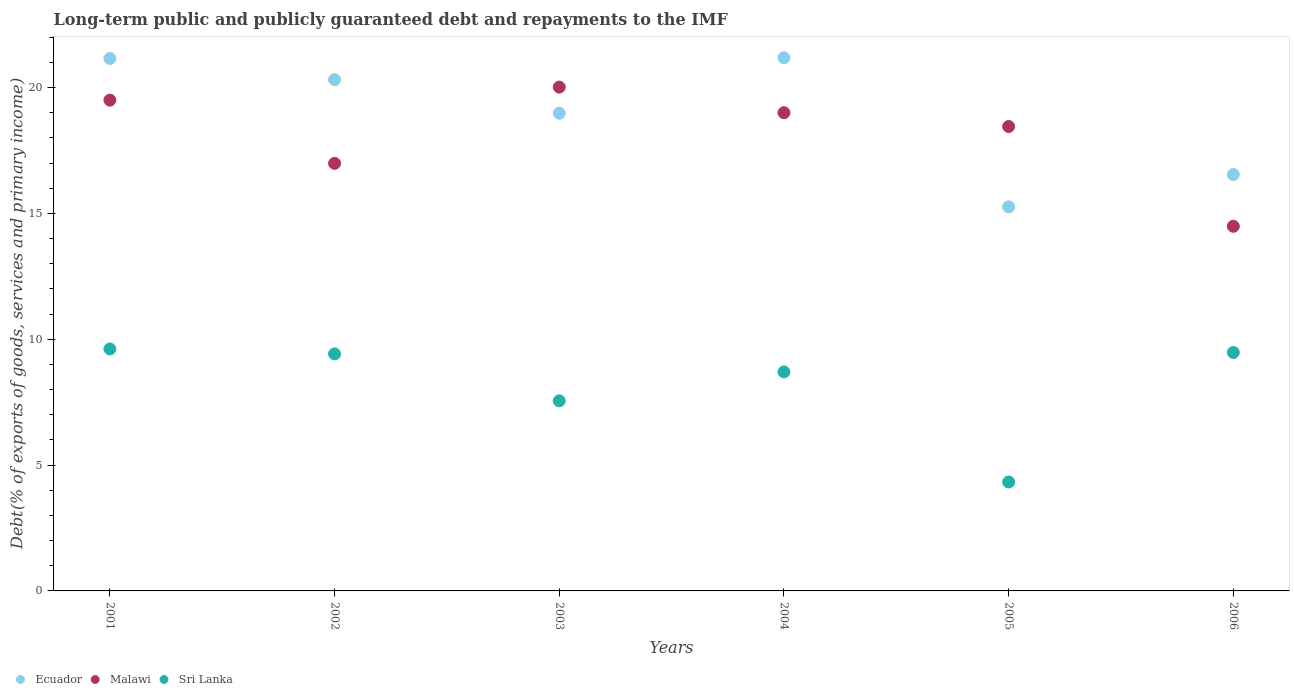Is the number of dotlines equal to the number of legend labels?
Your answer should be compact. Yes. What is the debt and repayments in Sri Lanka in 2002?
Your answer should be very brief. 9.42. Across all years, what is the maximum debt and repayments in Ecuador?
Provide a succinct answer. 21.18. Across all years, what is the minimum debt and repayments in Sri Lanka?
Your answer should be compact. 4.33. In which year was the debt and repayments in Sri Lanka minimum?
Provide a short and direct response. 2005. What is the total debt and repayments in Ecuador in the graph?
Give a very brief answer. 113.44. What is the difference between the debt and repayments in Ecuador in 2004 and that in 2005?
Make the answer very short. 5.92. What is the difference between the debt and repayments in Malawi in 2006 and the debt and repayments in Ecuador in 2001?
Offer a very short reply. -6.67. What is the average debt and repayments in Ecuador per year?
Provide a short and direct response. 18.91. In the year 2005, what is the difference between the debt and repayments in Ecuador and debt and repayments in Malawi?
Keep it short and to the point. -3.19. In how many years, is the debt and repayments in Malawi greater than 4 %?
Offer a very short reply. 6. What is the ratio of the debt and repayments in Malawi in 2002 to that in 2003?
Offer a very short reply. 0.85. Is the debt and repayments in Sri Lanka in 2004 less than that in 2005?
Your answer should be compact. No. Is the difference between the debt and repayments in Ecuador in 2002 and 2006 greater than the difference between the debt and repayments in Malawi in 2002 and 2006?
Make the answer very short. Yes. What is the difference between the highest and the second highest debt and repayments in Ecuador?
Keep it short and to the point. 0.03. What is the difference between the highest and the lowest debt and repayments in Ecuador?
Your answer should be compact. 5.92. In how many years, is the debt and repayments in Malawi greater than the average debt and repayments in Malawi taken over all years?
Offer a very short reply. 4. Is the sum of the debt and repayments in Malawi in 2003 and 2005 greater than the maximum debt and repayments in Ecuador across all years?
Give a very brief answer. Yes. Is it the case that in every year, the sum of the debt and repayments in Malawi and debt and repayments in Ecuador  is greater than the debt and repayments in Sri Lanka?
Ensure brevity in your answer.  Yes. Is the debt and repayments in Ecuador strictly greater than the debt and repayments in Sri Lanka over the years?
Provide a succinct answer. Yes. Is the debt and repayments in Sri Lanka strictly less than the debt and repayments in Malawi over the years?
Ensure brevity in your answer.  Yes. What is the difference between two consecutive major ticks on the Y-axis?
Your answer should be very brief. 5. Does the graph contain any zero values?
Offer a very short reply. No. Does the graph contain grids?
Give a very brief answer. No. Where does the legend appear in the graph?
Give a very brief answer. Bottom left. What is the title of the graph?
Provide a short and direct response. Long-term public and publicly guaranteed debt and repayments to the IMF. Does "Least developed countries" appear as one of the legend labels in the graph?
Provide a succinct answer. No. What is the label or title of the X-axis?
Make the answer very short. Years. What is the label or title of the Y-axis?
Your answer should be compact. Debt(% of exports of goods, services and primary income). What is the Debt(% of exports of goods, services and primary income) in Ecuador in 2001?
Provide a succinct answer. 21.15. What is the Debt(% of exports of goods, services and primary income) in Malawi in 2001?
Ensure brevity in your answer.  19.5. What is the Debt(% of exports of goods, services and primary income) in Sri Lanka in 2001?
Provide a short and direct response. 9.61. What is the Debt(% of exports of goods, services and primary income) in Ecuador in 2002?
Your response must be concise. 20.32. What is the Debt(% of exports of goods, services and primary income) in Malawi in 2002?
Give a very brief answer. 16.99. What is the Debt(% of exports of goods, services and primary income) of Sri Lanka in 2002?
Make the answer very short. 9.42. What is the Debt(% of exports of goods, services and primary income) of Ecuador in 2003?
Your answer should be very brief. 18.98. What is the Debt(% of exports of goods, services and primary income) in Malawi in 2003?
Give a very brief answer. 20.02. What is the Debt(% of exports of goods, services and primary income) in Sri Lanka in 2003?
Your response must be concise. 7.55. What is the Debt(% of exports of goods, services and primary income) of Ecuador in 2004?
Give a very brief answer. 21.18. What is the Debt(% of exports of goods, services and primary income) of Malawi in 2004?
Make the answer very short. 19. What is the Debt(% of exports of goods, services and primary income) of Sri Lanka in 2004?
Offer a very short reply. 8.7. What is the Debt(% of exports of goods, services and primary income) in Ecuador in 2005?
Give a very brief answer. 15.26. What is the Debt(% of exports of goods, services and primary income) in Malawi in 2005?
Give a very brief answer. 18.45. What is the Debt(% of exports of goods, services and primary income) in Sri Lanka in 2005?
Provide a succinct answer. 4.33. What is the Debt(% of exports of goods, services and primary income) of Ecuador in 2006?
Your response must be concise. 16.54. What is the Debt(% of exports of goods, services and primary income) of Malawi in 2006?
Offer a very short reply. 14.49. What is the Debt(% of exports of goods, services and primary income) in Sri Lanka in 2006?
Provide a short and direct response. 9.47. Across all years, what is the maximum Debt(% of exports of goods, services and primary income) in Ecuador?
Your answer should be very brief. 21.18. Across all years, what is the maximum Debt(% of exports of goods, services and primary income) of Malawi?
Offer a terse response. 20.02. Across all years, what is the maximum Debt(% of exports of goods, services and primary income) of Sri Lanka?
Provide a short and direct response. 9.61. Across all years, what is the minimum Debt(% of exports of goods, services and primary income) in Ecuador?
Make the answer very short. 15.26. Across all years, what is the minimum Debt(% of exports of goods, services and primary income) of Malawi?
Ensure brevity in your answer.  14.49. Across all years, what is the minimum Debt(% of exports of goods, services and primary income) in Sri Lanka?
Your answer should be very brief. 4.33. What is the total Debt(% of exports of goods, services and primary income) of Ecuador in the graph?
Your answer should be compact. 113.44. What is the total Debt(% of exports of goods, services and primary income) in Malawi in the graph?
Provide a short and direct response. 108.45. What is the total Debt(% of exports of goods, services and primary income) of Sri Lanka in the graph?
Provide a succinct answer. 49.09. What is the difference between the Debt(% of exports of goods, services and primary income) of Ecuador in 2001 and that in 2002?
Your answer should be very brief. 0.84. What is the difference between the Debt(% of exports of goods, services and primary income) of Malawi in 2001 and that in 2002?
Your answer should be very brief. 2.51. What is the difference between the Debt(% of exports of goods, services and primary income) in Sri Lanka in 2001 and that in 2002?
Your answer should be compact. 0.2. What is the difference between the Debt(% of exports of goods, services and primary income) of Ecuador in 2001 and that in 2003?
Make the answer very short. 2.17. What is the difference between the Debt(% of exports of goods, services and primary income) of Malawi in 2001 and that in 2003?
Your answer should be compact. -0.52. What is the difference between the Debt(% of exports of goods, services and primary income) of Sri Lanka in 2001 and that in 2003?
Keep it short and to the point. 2.06. What is the difference between the Debt(% of exports of goods, services and primary income) in Ecuador in 2001 and that in 2004?
Make the answer very short. -0.03. What is the difference between the Debt(% of exports of goods, services and primary income) of Malawi in 2001 and that in 2004?
Your answer should be compact. 0.5. What is the difference between the Debt(% of exports of goods, services and primary income) of Sri Lanka in 2001 and that in 2004?
Offer a terse response. 0.91. What is the difference between the Debt(% of exports of goods, services and primary income) in Ecuador in 2001 and that in 2005?
Offer a very short reply. 5.89. What is the difference between the Debt(% of exports of goods, services and primary income) in Malawi in 2001 and that in 2005?
Ensure brevity in your answer.  1.05. What is the difference between the Debt(% of exports of goods, services and primary income) of Sri Lanka in 2001 and that in 2005?
Your response must be concise. 5.29. What is the difference between the Debt(% of exports of goods, services and primary income) of Ecuador in 2001 and that in 2006?
Provide a short and direct response. 4.61. What is the difference between the Debt(% of exports of goods, services and primary income) of Malawi in 2001 and that in 2006?
Your answer should be very brief. 5.01. What is the difference between the Debt(% of exports of goods, services and primary income) of Sri Lanka in 2001 and that in 2006?
Provide a short and direct response. 0.14. What is the difference between the Debt(% of exports of goods, services and primary income) of Ecuador in 2002 and that in 2003?
Give a very brief answer. 1.34. What is the difference between the Debt(% of exports of goods, services and primary income) of Malawi in 2002 and that in 2003?
Your answer should be very brief. -3.03. What is the difference between the Debt(% of exports of goods, services and primary income) in Sri Lanka in 2002 and that in 2003?
Your answer should be very brief. 1.86. What is the difference between the Debt(% of exports of goods, services and primary income) in Ecuador in 2002 and that in 2004?
Give a very brief answer. -0.87. What is the difference between the Debt(% of exports of goods, services and primary income) of Malawi in 2002 and that in 2004?
Provide a succinct answer. -2.01. What is the difference between the Debt(% of exports of goods, services and primary income) of Sri Lanka in 2002 and that in 2004?
Give a very brief answer. 0.72. What is the difference between the Debt(% of exports of goods, services and primary income) in Ecuador in 2002 and that in 2005?
Your response must be concise. 5.06. What is the difference between the Debt(% of exports of goods, services and primary income) of Malawi in 2002 and that in 2005?
Provide a short and direct response. -1.46. What is the difference between the Debt(% of exports of goods, services and primary income) in Sri Lanka in 2002 and that in 2005?
Provide a short and direct response. 5.09. What is the difference between the Debt(% of exports of goods, services and primary income) of Ecuador in 2002 and that in 2006?
Keep it short and to the point. 3.77. What is the difference between the Debt(% of exports of goods, services and primary income) of Malawi in 2002 and that in 2006?
Offer a terse response. 2.5. What is the difference between the Debt(% of exports of goods, services and primary income) in Sri Lanka in 2002 and that in 2006?
Keep it short and to the point. -0.06. What is the difference between the Debt(% of exports of goods, services and primary income) in Ecuador in 2003 and that in 2004?
Your response must be concise. -2.2. What is the difference between the Debt(% of exports of goods, services and primary income) in Malawi in 2003 and that in 2004?
Ensure brevity in your answer.  1.02. What is the difference between the Debt(% of exports of goods, services and primary income) of Sri Lanka in 2003 and that in 2004?
Keep it short and to the point. -1.15. What is the difference between the Debt(% of exports of goods, services and primary income) of Ecuador in 2003 and that in 2005?
Provide a short and direct response. 3.72. What is the difference between the Debt(% of exports of goods, services and primary income) of Malawi in 2003 and that in 2005?
Make the answer very short. 1.56. What is the difference between the Debt(% of exports of goods, services and primary income) of Sri Lanka in 2003 and that in 2005?
Your response must be concise. 3.23. What is the difference between the Debt(% of exports of goods, services and primary income) in Ecuador in 2003 and that in 2006?
Ensure brevity in your answer.  2.44. What is the difference between the Debt(% of exports of goods, services and primary income) in Malawi in 2003 and that in 2006?
Your answer should be compact. 5.53. What is the difference between the Debt(% of exports of goods, services and primary income) of Sri Lanka in 2003 and that in 2006?
Provide a succinct answer. -1.92. What is the difference between the Debt(% of exports of goods, services and primary income) in Ecuador in 2004 and that in 2005?
Your answer should be very brief. 5.92. What is the difference between the Debt(% of exports of goods, services and primary income) in Malawi in 2004 and that in 2005?
Your answer should be very brief. 0.55. What is the difference between the Debt(% of exports of goods, services and primary income) in Sri Lanka in 2004 and that in 2005?
Give a very brief answer. 4.37. What is the difference between the Debt(% of exports of goods, services and primary income) in Ecuador in 2004 and that in 2006?
Your answer should be very brief. 4.64. What is the difference between the Debt(% of exports of goods, services and primary income) of Malawi in 2004 and that in 2006?
Provide a succinct answer. 4.51. What is the difference between the Debt(% of exports of goods, services and primary income) in Sri Lanka in 2004 and that in 2006?
Offer a terse response. -0.77. What is the difference between the Debt(% of exports of goods, services and primary income) in Ecuador in 2005 and that in 2006?
Your answer should be very brief. -1.28. What is the difference between the Debt(% of exports of goods, services and primary income) in Malawi in 2005 and that in 2006?
Provide a succinct answer. 3.97. What is the difference between the Debt(% of exports of goods, services and primary income) of Sri Lanka in 2005 and that in 2006?
Ensure brevity in your answer.  -5.15. What is the difference between the Debt(% of exports of goods, services and primary income) of Ecuador in 2001 and the Debt(% of exports of goods, services and primary income) of Malawi in 2002?
Give a very brief answer. 4.17. What is the difference between the Debt(% of exports of goods, services and primary income) of Ecuador in 2001 and the Debt(% of exports of goods, services and primary income) of Sri Lanka in 2002?
Your response must be concise. 11.74. What is the difference between the Debt(% of exports of goods, services and primary income) in Malawi in 2001 and the Debt(% of exports of goods, services and primary income) in Sri Lanka in 2002?
Your answer should be compact. 10.08. What is the difference between the Debt(% of exports of goods, services and primary income) in Ecuador in 2001 and the Debt(% of exports of goods, services and primary income) in Malawi in 2003?
Offer a very short reply. 1.14. What is the difference between the Debt(% of exports of goods, services and primary income) in Ecuador in 2001 and the Debt(% of exports of goods, services and primary income) in Sri Lanka in 2003?
Your answer should be very brief. 13.6. What is the difference between the Debt(% of exports of goods, services and primary income) in Malawi in 2001 and the Debt(% of exports of goods, services and primary income) in Sri Lanka in 2003?
Keep it short and to the point. 11.95. What is the difference between the Debt(% of exports of goods, services and primary income) of Ecuador in 2001 and the Debt(% of exports of goods, services and primary income) of Malawi in 2004?
Offer a terse response. 2.15. What is the difference between the Debt(% of exports of goods, services and primary income) in Ecuador in 2001 and the Debt(% of exports of goods, services and primary income) in Sri Lanka in 2004?
Ensure brevity in your answer.  12.45. What is the difference between the Debt(% of exports of goods, services and primary income) in Malawi in 2001 and the Debt(% of exports of goods, services and primary income) in Sri Lanka in 2004?
Your answer should be very brief. 10.8. What is the difference between the Debt(% of exports of goods, services and primary income) in Ecuador in 2001 and the Debt(% of exports of goods, services and primary income) in Malawi in 2005?
Keep it short and to the point. 2.7. What is the difference between the Debt(% of exports of goods, services and primary income) in Ecuador in 2001 and the Debt(% of exports of goods, services and primary income) in Sri Lanka in 2005?
Give a very brief answer. 16.83. What is the difference between the Debt(% of exports of goods, services and primary income) of Malawi in 2001 and the Debt(% of exports of goods, services and primary income) of Sri Lanka in 2005?
Keep it short and to the point. 15.17. What is the difference between the Debt(% of exports of goods, services and primary income) in Ecuador in 2001 and the Debt(% of exports of goods, services and primary income) in Malawi in 2006?
Your answer should be very brief. 6.67. What is the difference between the Debt(% of exports of goods, services and primary income) of Ecuador in 2001 and the Debt(% of exports of goods, services and primary income) of Sri Lanka in 2006?
Offer a very short reply. 11.68. What is the difference between the Debt(% of exports of goods, services and primary income) in Malawi in 2001 and the Debt(% of exports of goods, services and primary income) in Sri Lanka in 2006?
Give a very brief answer. 10.03. What is the difference between the Debt(% of exports of goods, services and primary income) of Ecuador in 2002 and the Debt(% of exports of goods, services and primary income) of Malawi in 2003?
Ensure brevity in your answer.  0.3. What is the difference between the Debt(% of exports of goods, services and primary income) of Ecuador in 2002 and the Debt(% of exports of goods, services and primary income) of Sri Lanka in 2003?
Your response must be concise. 12.76. What is the difference between the Debt(% of exports of goods, services and primary income) in Malawi in 2002 and the Debt(% of exports of goods, services and primary income) in Sri Lanka in 2003?
Provide a succinct answer. 9.44. What is the difference between the Debt(% of exports of goods, services and primary income) of Ecuador in 2002 and the Debt(% of exports of goods, services and primary income) of Malawi in 2004?
Your response must be concise. 1.31. What is the difference between the Debt(% of exports of goods, services and primary income) in Ecuador in 2002 and the Debt(% of exports of goods, services and primary income) in Sri Lanka in 2004?
Provide a short and direct response. 11.61. What is the difference between the Debt(% of exports of goods, services and primary income) of Malawi in 2002 and the Debt(% of exports of goods, services and primary income) of Sri Lanka in 2004?
Your response must be concise. 8.29. What is the difference between the Debt(% of exports of goods, services and primary income) of Ecuador in 2002 and the Debt(% of exports of goods, services and primary income) of Malawi in 2005?
Your answer should be very brief. 1.86. What is the difference between the Debt(% of exports of goods, services and primary income) of Ecuador in 2002 and the Debt(% of exports of goods, services and primary income) of Sri Lanka in 2005?
Offer a terse response. 15.99. What is the difference between the Debt(% of exports of goods, services and primary income) in Malawi in 2002 and the Debt(% of exports of goods, services and primary income) in Sri Lanka in 2005?
Give a very brief answer. 12.66. What is the difference between the Debt(% of exports of goods, services and primary income) in Ecuador in 2002 and the Debt(% of exports of goods, services and primary income) in Malawi in 2006?
Keep it short and to the point. 5.83. What is the difference between the Debt(% of exports of goods, services and primary income) in Ecuador in 2002 and the Debt(% of exports of goods, services and primary income) in Sri Lanka in 2006?
Give a very brief answer. 10.84. What is the difference between the Debt(% of exports of goods, services and primary income) in Malawi in 2002 and the Debt(% of exports of goods, services and primary income) in Sri Lanka in 2006?
Your response must be concise. 7.51. What is the difference between the Debt(% of exports of goods, services and primary income) of Ecuador in 2003 and the Debt(% of exports of goods, services and primary income) of Malawi in 2004?
Give a very brief answer. -0.02. What is the difference between the Debt(% of exports of goods, services and primary income) of Ecuador in 2003 and the Debt(% of exports of goods, services and primary income) of Sri Lanka in 2004?
Your answer should be compact. 10.28. What is the difference between the Debt(% of exports of goods, services and primary income) in Malawi in 2003 and the Debt(% of exports of goods, services and primary income) in Sri Lanka in 2004?
Give a very brief answer. 11.32. What is the difference between the Debt(% of exports of goods, services and primary income) in Ecuador in 2003 and the Debt(% of exports of goods, services and primary income) in Malawi in 2005?
Your answer should be very brief. 0.53. What is the difference between the Debt(% of exports of goods, services and primary income) in Ecuador in 2003 and the Debt(% of exports of goods, services and primary income) in Sri Lanka in 2005?
Offer a terse response. 14.65. What is the difference between the Debt(% of exports of goods, services and primary income) of Malawi in 2003 and the Debt(% of exports of goods, services and primary income) of Sri Lanka in 2005?
Provide a succinct answer. 15.69. What is the difference between the Debt(% of exports of goods, services and primary income) of Ecuador in 2003 and the Debt(% of exports of goods, services and primary income) of Malawi in 2006?
Provide a succinct answer. 4.49. What is the difference between the Debt(% of exports of goods, services and primary income) of Ecuador in 2003 and the Debt(% of exports of goods, services and primary income) of Sri Lanka in 2006?
Provide a succinct answer. 9.51. What is the difference between the Debt(% of exports of goods, services and primary income) of Malawi in 2003 and the Debt(% of exports of goods, services and primary income) of Sri Lanka in 2006?
Your answer should be compact. 10.54. What is the difference between the Debt(% of exports of goods, services and primary income) in Ecuador in 2004 and the Debt(% of exports of goods, services and primary income) in Malawi in 2005?
Give a very brief answer. 2.73. What is the difference between the Debt(% of exports of goods, services and primary income) in Ecuador in 2004 and the Debt(% of exports of goods, services and primary income) in Sri Lanka in 2005?
Offer a terse response. 16.86. What is the difference between the Debt(% of exports of goods, services and primary income) in Malawi in 2004 and the Debt(% of exports of goods, services and primary income) in Sri Lanka in 2005?
Your answer should be very brief. 14.67. What is the difference between the Debt(% of exports of goods, services and primary income) of Ecuador in 2004 and the Debt(% of exports of goods, services and primary income) of Malawi in 2006?
Your answer should be very brief. 6.69. What is the difference between the Debt(% of exports of goods, services and primary income) in Ecuador in 2004 and the Debt(% of exports of goods, services and primary income) in Sri Lanka in 2006?
Make the answer very short. 11.71. What is the difference between the Debt(% of exports of goods, services and primary income) in Malawi in 2004 and the Debt(% of exports of goods, services and primary income) in Sri Lanka in 2006?
Make the answer very short. 9.53. What is the difference between the Debt(% of exports of goods, services and primary income) of Ecuador in 2005 and the Debt(% of exports of goods, services and primary income) of Malawi in 2006?
Your answer should be very brief. 0.77. What is the difference between the Debt(% of exports of goods, services and primary income) in Ecuador in 2005 and the Debt(% of exports of goods, services and primary income) in Sri Lanka in 2006?
Keep it short and to the point. 5.79. What is the difference between the Debt(% of exports of goods, services and primary income) in Malawi in 2005 and the Debt(% of exports of goods, services and primary income) in Sri Lanka in 2006?
Keep it short and to the point. 8.98. What is the average Debt(% of exports of goods, services and primary income) of Ecuador per year?
Your answer should be compact. 18.91. What is the average Debt(% of exports of goods, services and primary income) in Malawi per year?
Your answer should be very brief. 18.08. What is the average Debt(% of exports of goods, services and primary income) in Sri Lanka per year?
Your answer should be compact. 8.18. In the year 2001, what is the difference between the Debt(% of exports of goods, services and primary income) of Ecuador and Debt(% of exports of goods, services and primary income) of Malawi?
Your answer should be very brief. 1.65. In the year 2001, what is the difference between the Debt(% of exports of goods, services and primary income) of Ecuador and Debt(% of exports of goods, services and primary income) of Sri Lanka?
Ensure brevity in your answer.  11.54. In the year 2001, what is the difference between the Debt(% of exports of goods, services and primary income) of Malawi and Debt(% of exports of goods, services and primary income) of Sri Lanka?
Your answer should be compact. 9.89. In the year 2002, what is the difference between the Debt(% of exports of goods, services and primary income) of Ecuador and Debt(% of exports of goods, services and primary income) of Malawi?
Give a very brief answer. 3.33. In the year 2002, what is the difference between the Debt(% of exports of goods, services and primary income) of Ecuador and Debt(% of exports of goods, services and primary income) of Sri Lanka?
Keep it short and to the point. 10.9. In the year 2002, what is the difference between the Debt(% of exports of goods, services and primary income) in Malawi and Debt(% of exports of goods, services and primary income) in Sri Lanka?
Give a very brief answer. 7.57. In the year 2003, what is the difference between the Debt(% of exports of goods, services and primary income) in Ecuador and Debt(% of exports of goods, services and primary income) in Malawi?
Keep it short and to the point. -1.04. In the year 2003, what is the difference between the Debt(% of exports of goods, services and primary income) in Ecuador and Debt(% of exports of goods, services and primary income) in Sri Lanka?
Your answer should be very brief. 11.43. In the year 2003, what is the difference between the Debt(% of exports of goods, services and primary income) in Malawi and Debt(% of exports of goods, services and primary income) in Sri Lanka?
Offer a very short reply. 12.46. In the year 2004, what is the difference between the Debt(% of exports of goods, services and primary income) in Ecuador and Debt(% of exports of goods, services and primary income) in Malawi?
Keep it short and to the point. 2.18. In the year 2004, what is the difference between the Debt(% of exports of goods, services and primary income) in Ecuador and Debt(% of exports of goods, services and primary income) in Sri Lanka?
Give a very brief answer. 12.48. In the year 2004, what is the difference between the Debt(% of exports of goods, services and primary income) in Malawi and Debt(% of exports of goods, services and primary income) in Sri Lanka?
Your answer should be very brief. 10.3. In the year 2005, what is the difference between the Debt(% of exports of goods, services and primary income) in Ecuador and Debt(% of exports of goods, services and primary income) in Malawi?
Your response must be concise. -3.19. In the year 2005, what is the difference between the Debt(% of exports of goods, services and primary income) in Ecuador and Debt(% of exports of goods, services and primary income) in Sri Lanka?
Your response must be concise. 10.93. In the year 2005, what is the difference between the Debt(% of exports of goods, services and primary income) of Malawi and Debt(% of exports of goods, services and primary income) of Sri Lanka?
Make the answer very short. 14.13. In the year 2006, what is the difference between the Debt(% of exports of goods, services and primary income) of Ecuador and Debt(% of exports of goods, services and primary income) of Malawi?
Offer a terse response. 2.06. In the year 2006, what is the difference between the Debt(% of exports of goods, services and primary income) of Ecuador and Debt(% of exports of goods, services and primary income) of Sri Lanka?
Your answer should be very brief. 7.07. In the year 2006, what is the difference between the Debt(% of exports of goods, services and primary income) of Malawi and Debt(% of exports of goods, services and primary income) of Sri Lanka?
Offer a very short reply. 5.01. What is the ratio of the Debt(% of exports of goods, services and primary income) of Ecuador in 2001 to that in 2002?
Keep it short and to the point. 1.04. What is the ratio of the Debt(% of exports of goods, services and primary income) in Malawi in 2001 to that in 2002?
Keep it short and to the point. 1.15. What is the ratio of the Debt(% of exports of goods, services and primary income) of Sri Lanka in 2001 to that in 2002?
Offer a terse response. 1.02. What is the ratio of the Debt(% of exports of goods, services and primary income) of Ecuador in 2001 to that in 2003?
Your answer should be very brief. 1.11. What is the ratio of the Debt(% of exports of goods, services and primary income) of Malawi in 2001 to that in 2003?
Provide a short and direct response. 0.97. What is the ratio of the Debt(% of exports of goods, services and primary income) in Sri Lanka in 2001 to that in 2003?
Provide a succinct answer. 1.27. What is the ratio of the Debt(% of exports of goods, services and primary income) in Ecuador in 2001 to that in 2004?
Ensure brevity in your answer.  1. What is the ratio of the Debt(% of exports of goods, services and primary income) of Malawi in 2001 to that in 2004?
Keep it short and to the point. 1.03. What is the ratio of the Debt(% of exports of goods, services and primary income) in Sri Lanka in 2001 to that in 2004?
Your response must be concise. 1.1. What is the ratio of the Debt(% of exports of goods, services and primary income) in Ecuador in 2001 to that in 2005?
Your answer should be compact. 1.39. What is the ratio of the Debt(% of exports of goods, services and primary income) of Malawi in 2001 to that in 2005?
Provide a short and direct response. 1.06. What is the ratio of the Debt(% of exports of goods, services and primary income) in Sri Lanka in 2001 to that in 2005?
Ensure brevity in your answer.  2.22. What is the ratio of the Debt(% of exports of goods, services and primary income) of Ecuador in 2001 to that in 2006?
Give a very brief answer. 1.28. What is the ratio of the Debt(% of exports of goods, services and primary income) in Malawi in 2001 to that in 2006?
Ensure brevity in your answer.  1.35. What is the ratio of the Debt(% of exports of goods, services and primary income) in Sri Lanka in 2001 to that in 2006?
Provide a short and direct response. 1.01. What is the ratio of the Debt(% of exports of goods, services and primary income) in Ecuador in 2002 to that in 2003?
Offer a terse response. 1.07. What is the ratio of the Debt(% of exports of goods, services and primary income) in Malawi in 2002 to that in 2003?
Offer a very short reply. 0.85. What is the ratio of the Debt(% of exports of goods, services and primary income) of Sri Lanka in 2002 to that in 2003?
Provide a succinct answer. 1.25. What is the ratio of the Debt(% of exports of goods, services and primary income) in Malawi in 2002 to that in 2004?
Provide a succinct answer. 0.89. What is the ratio of the Debt(% of exports of goods, services and primary income) of Sri Lanka in 2002 to that in 2004?
Make the answer very short. 1.08. What is the ratio of the Debt(% of exports of goods, services and primary income) of Ecuador in 2002 to that in 2005?
Your answer should be compact. 1.33. What is the ratio of the Debt(% of exports of goods, services and primary income) in Malawi in 2002 to that in 2005?
Your answer should be very brief. 0.92. What is the ratio of the Debt(% of exports of goods, services and primary income) of Sri Lanka in 2002 to that in 2005?
Your response must be concise. 2.18. What is the ratio of the Debt(% of exports of goods, services and primary income) of Ecuador in 2002 to that in 2006?
Give a very brief answer. 1.23. What is the ratio of the Debt(% of exports of goods, services and primary income) in Malawi in 2002 to that in 2006?
Provide a short and direct response. 1.17. What is the ratio of the Debt(% of exports of goods, services and primary income) of Ecuador in 2003 to that in 2004?
Offer a terse response. 0.9. What is the ratio of the Debt(% of exports of goods, services and primary income) of Malawi in 2003 to that in 2004?
Offer a terse response. 1.05. What is the ratio of the Debt(% of exports of goods, services and primary income) of Sri Lanka in 2003 to that in 2004?
Your answer should be very brief. 0.87. What is the ratio of the Debt(% of exports of goods, services and primary income) of Ecuador in 2003 to that in 2005?
Make the answer very short. 1.24. What is the ratio of the Debt(% of exports of goods, services and primary income) in Malawi in 2003 to that in 2005?
Your response must be concise. 1.08. What is the ratio of the Debt(% of exports of goods, services and primary income) of Sri Lanka in 2003 to that in 2005?
Your response must be concise. 1.75. What is the ratio of the Debt(% of exports of goods, services and primary income) of Ecuador in 2003 to that in 2006?
Your answer should be very brief. 1.15. What is the ratio of the Debt(% of exports of goods, services and primary income) in Malawi in 2003 to that in 2006?
Offer a terse response. 1.38. What is the ratio of the Debt(% of exports of goods, services and primary income) in Sri Lanka in 2003 to that in 2006?
Give a very brief answer. 0.8. What is the ratio of the Debt(% of exports of goods, services and primary income) of Ecuador in 2004 to that in 2005?
Your answer should be compact. 1.39. What is the ratio of the Debt(% of exports of goods, services and primary income) of Malawi in 2004 to that in 2005?
Offer a very short reply. 1.03. What is the ratio of the Debt(% of exports of goods, services and primary income) of Sri Lanka in 2004 to that in 2005?
Your answer should be very brief. 2.01. What is the ratio of the Debt(% of exports of goods, services and primary income) of Ecuador in 2004 to that in 2006?
Your answer should be compact. 1.28. What is the ratio of the Debt(% of exports of goods, services and primary income) of Malawi in 2004 to that in 2006?
Provide a succinct answer. 1.31. What is the ratio of the Debt(% of exports of goods, services and primary income) of Sri Lanka in 2004 to that in 2006?
Your response must be concise. 0.92. What is the ratio of the Debt(% of exports of goods, services and primary income) of Ecuador in 2005 to that in 2006?
Your answer should be very brief. 0.92. What is the ratio of the Debt(% of exports of goods, services and primary income) in Malawi in 2005 to that in 2006?
Give a very brief answer. 1.27. What is the ratio of the Debt(% of exports of goods, services and primary income) in Sri Lanka in 2005 to that in 2006?
Ensure brevity in your answer.  0.46. What is the difference between the highest and the second highest Debt(% of exports of goods, services and primary income) in Ecuador?
Keep it short and to the point. 0.03. What is the difference between the highest and the second highest Debt(% of exports of goods, services and primary income) of Malawi?
Make the answer very short. 0.52. What is the difference between the highest and the second highest Debt(% of exports of goods, services and primary income) of Sri Lanka?
Make the answer very short. 0.14. What is the difference between the highest and the lowest Debt(% of exports of goods, services and primary income) of Ecuador?
Provide a succinct answer. 5.92. What is the difference between the highest and the lowest Debt(% of exports of goods, services and primary income) in Malawi?
Provide a short and direct response. 5.53. What is the difference between the highest and the lowest Debt(% of exports of goods, services and primary income) in Sri Lanka?
Offer a terse response. 5.29. 